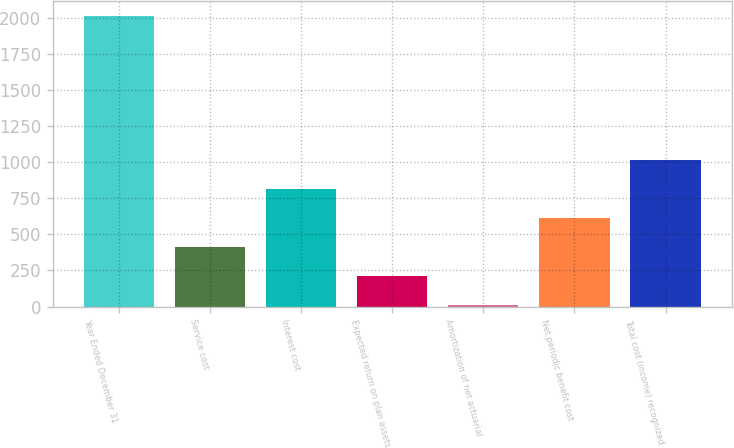<chart> <loc_0><loc_0><loc_500><loc_500><bar_chart><fcel>Year Ended December 31<fcel>Service cost<fcel>Interest cost<fcel>Expected return on plan assets<fcel>Amortization of net actuarial<fcel>Net periodic benefit cost<fcel>Total cost (income) recognized<nl><fcel>2017<fcel>409.8<fcel>811.6<fcel>208.9<fcel>8<fcel>610.7<fcel>1012.5<nl></chart> 